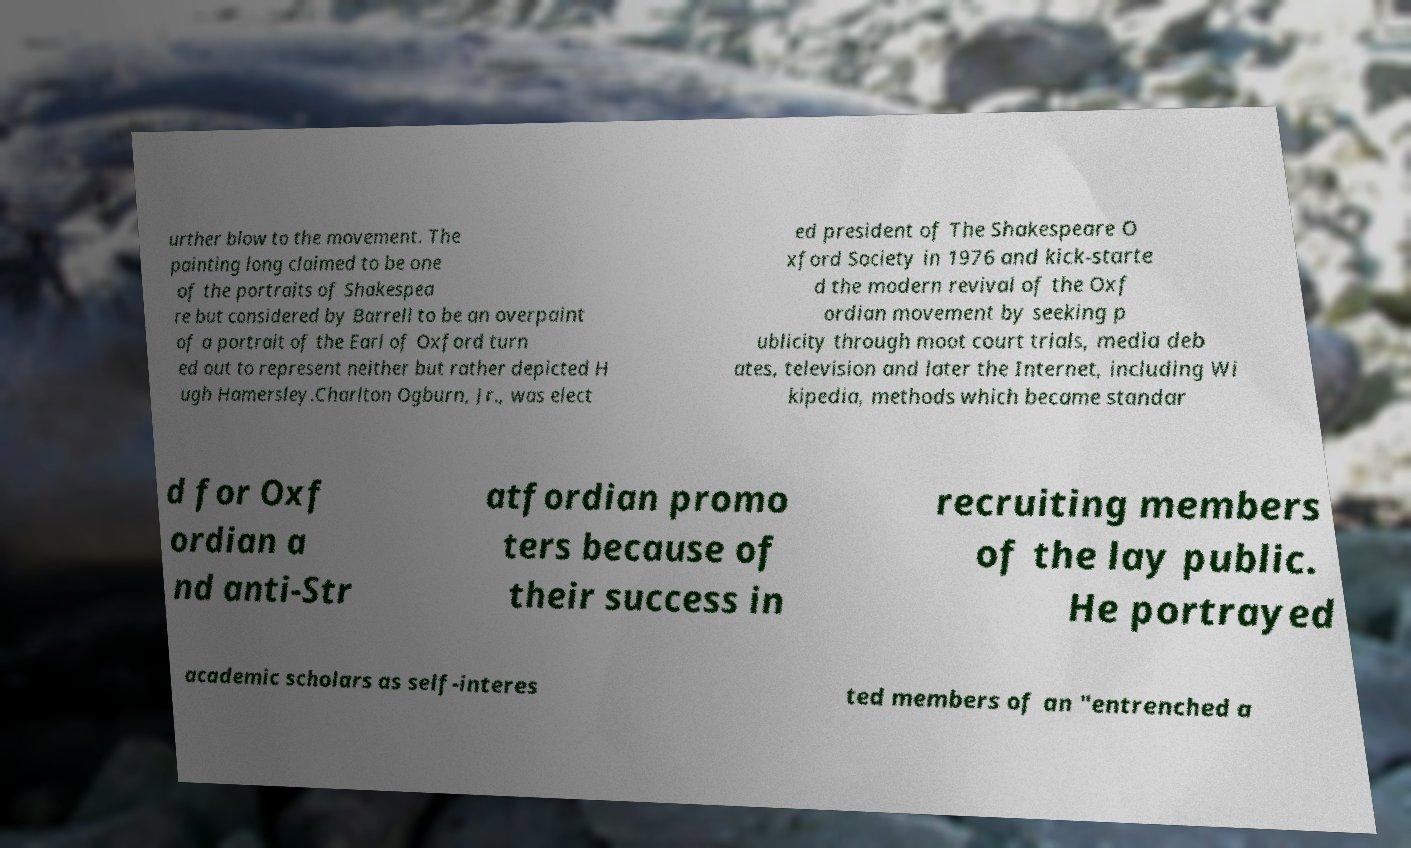For documentation purposes, I need the text within this image transcribed. Could you provide that? urther blow to the movement. The painting long claimed to be one of the portraits of Shakespea re but considered by Barrell to be an overpaint of a portrait of the Earl of Oxford turn ed out to represent neither but rather depicted H ugh Hamersley.Charlton Ogburn, Jr., was elect ed president of The Shakespeare O xford Society in 1976 and kick-starte d the modern revival of the Oxf ordian movement by seeking p ublicity through moot court trials, media deb ates, television and later the Internet, including Wi kipedia, methods which became standar d for Oxf ordian a nd anti-Str atfordian promo ters because of their success in recruiting members of the lay public. He portrayed academic scholars as self-interes ted members of an "entrenched a 